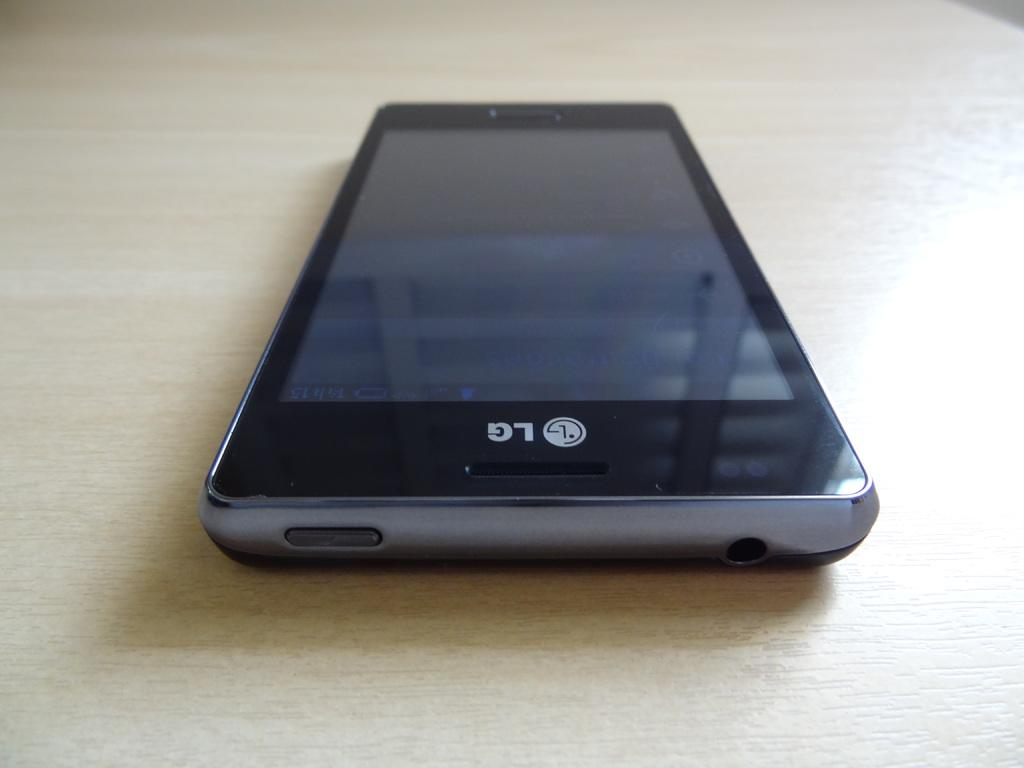<image>
Create a compact narrative representing the image presented. An LG phone that is currently turned off sits on a blank flat surface. 